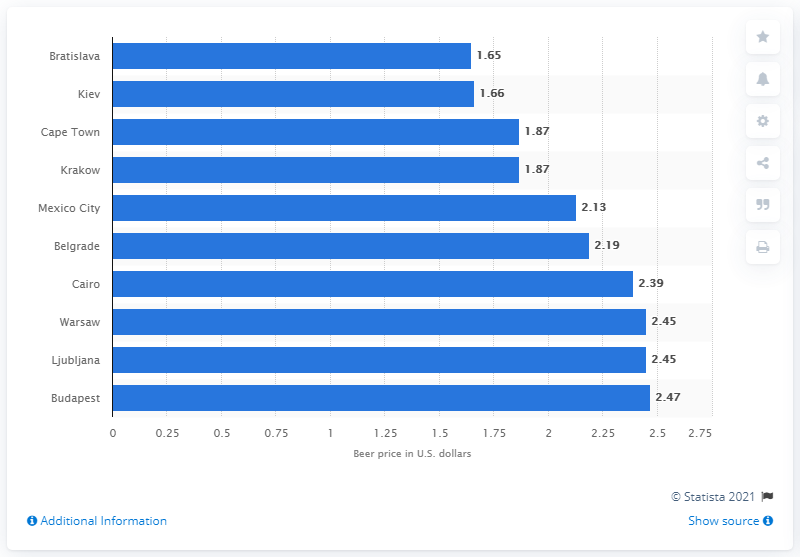Highlight a few significant elements in this photo. Bratislava was found to be the cheapest city for purchasing a beer. 